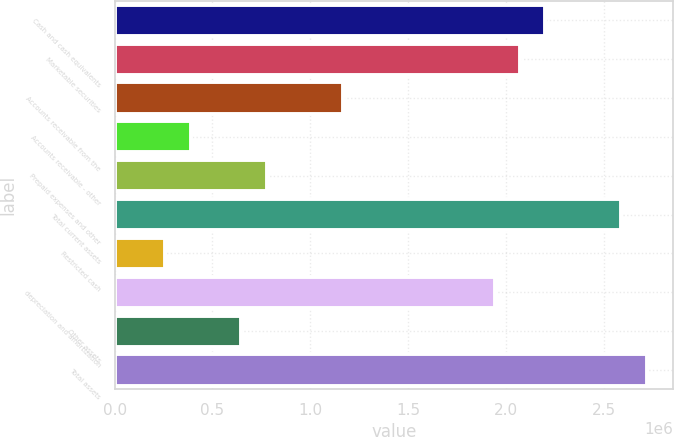Convert chart to OTSL. <chart><loc_0><loc_0><loc_500><loc_500><bar_chart><fcel>Cash and cash equivalents<fcel>Marketable securities<fcel>Accounts receivable from the<fcel>Accounts receivable - other<fcel>Prepaid expenses and other<fcel>Total current assets<fcel>Restricted cash<fcel>depreciation and amortization<fcel>Other assets<fcel>Total assets<nl><fcel>2.20113e+06<fcel>2.07165e+06<fcel>1.16534e+06<fcel>388498<fcel>776919<fcel>2.58955e+06<fcel>259025<fcel>1.94218e+06<fcel>647446<fcel>2.71902e+06<nl></chart> 